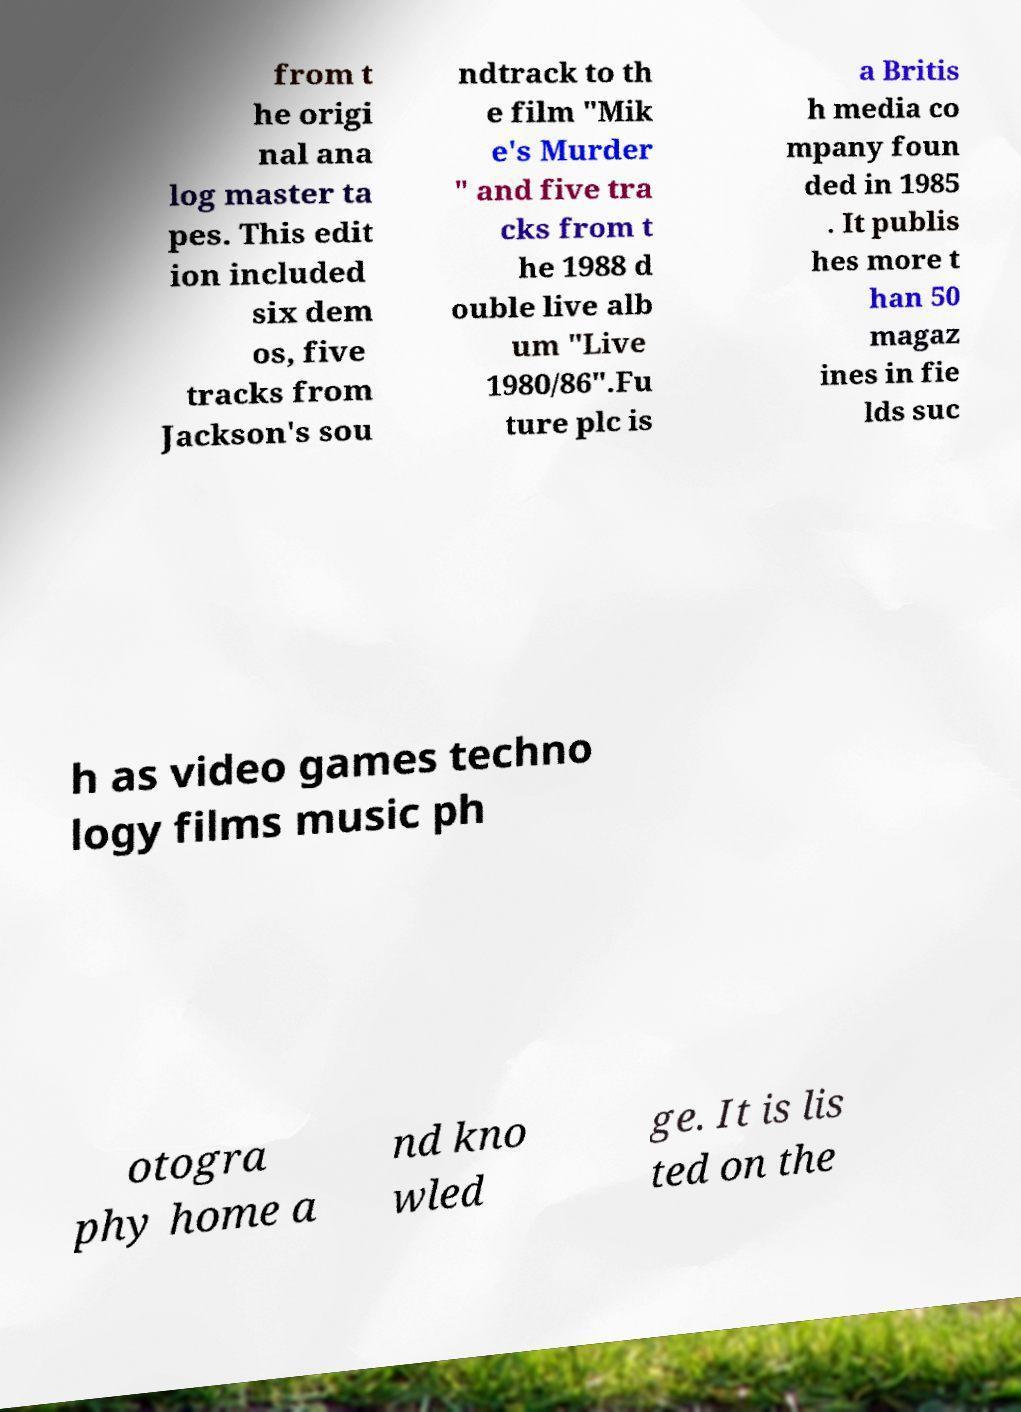What messages or text are displayed in this image? I need them in a readable, typed format. from t he origi nal ana log master ta pes. This edit ion included six dem os, five tracks from Jackson's sou ndtrack to th e film "Mik e's Murder " and five tra cks from t he 1988 d ouble live alb um "Live 1980/86".Fu ture plc is a Britis h media co mpany foun ded in 1985 . It publis hes more t han 50 magaz ines in fie lds suc h as video games techno logy films music ph otogra phy home a nd kno wled ge. It is lis ted on the 